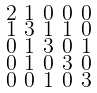Convert formula to latex. <formula><loc_0><loc_0><loc_500><loc_500>\begin{smallmatrix} 2 & 1 & 0 & 0 & 0 \\ 1 & 3 & 1 & 1 & 0 \\ 0 & 1 & 3 & 0 & 1 \\ 0 & 1 & 0 & 3 & 0 \\ 0 & 0 & 1 & 0 & 3 \end{smallmatrix}</formula> 